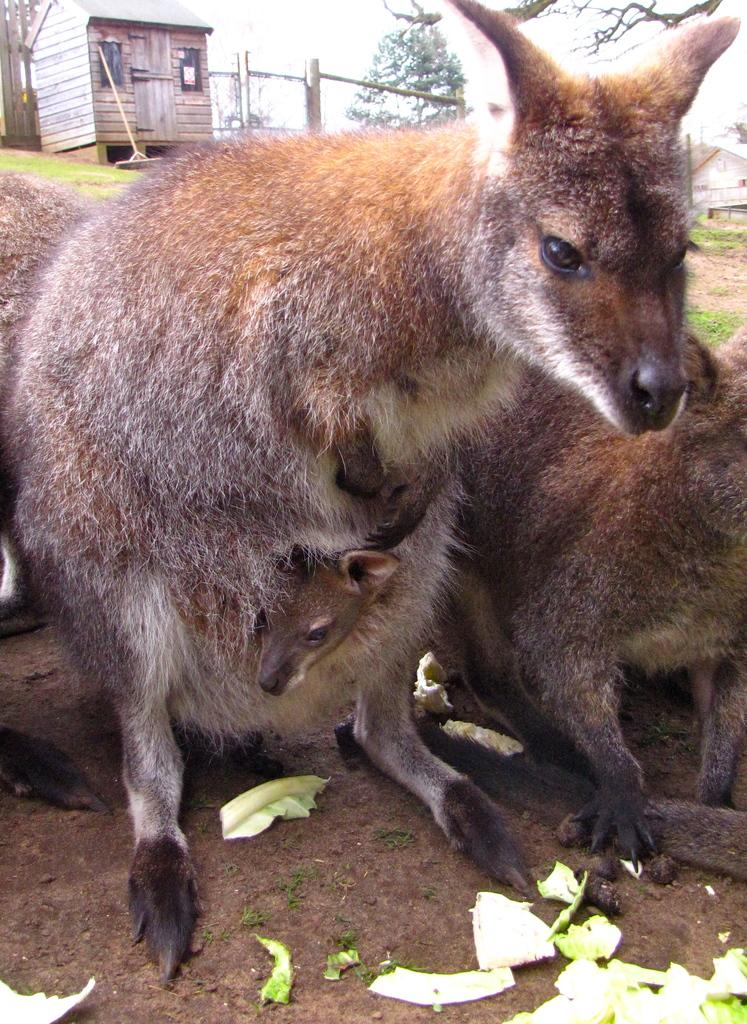What types of living organisms can be seen in the image? There are animals in the image. What structure is visible in the background of the image? There is a shed in the background of the image. What type of natural environment is visible in the background of the image? There are trees in the background of the image. What part of the natural environment is visible in the image? The sky is visible in the image. What type of food can be seen at the bottom of the image? There are vegetables at the bottom of the image. What type of sock is hanging on the alarm in the image? There is no sock or alarm present in the image. What type of learning material is visible in the image? There is no learning material visible in the image. 